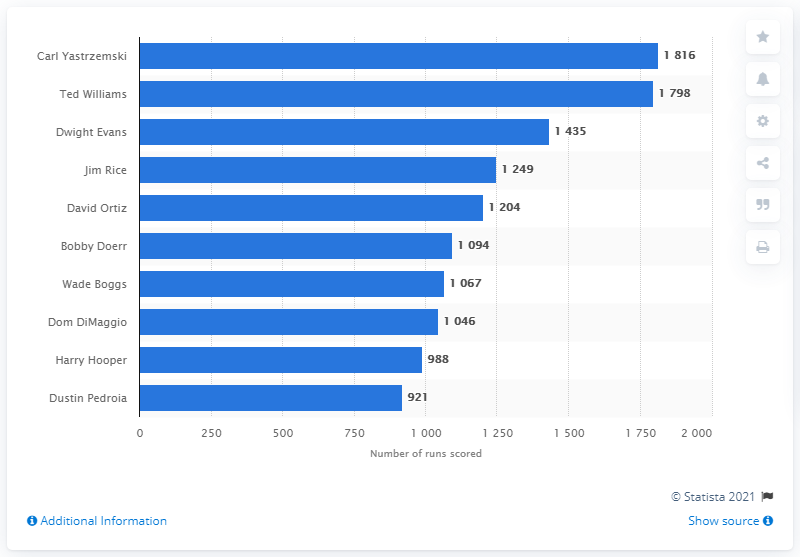Point out several critical features in this image. The individual who has accumulated the most runs in the history of the Red Sox franchise is Carl Yastrzemski. 